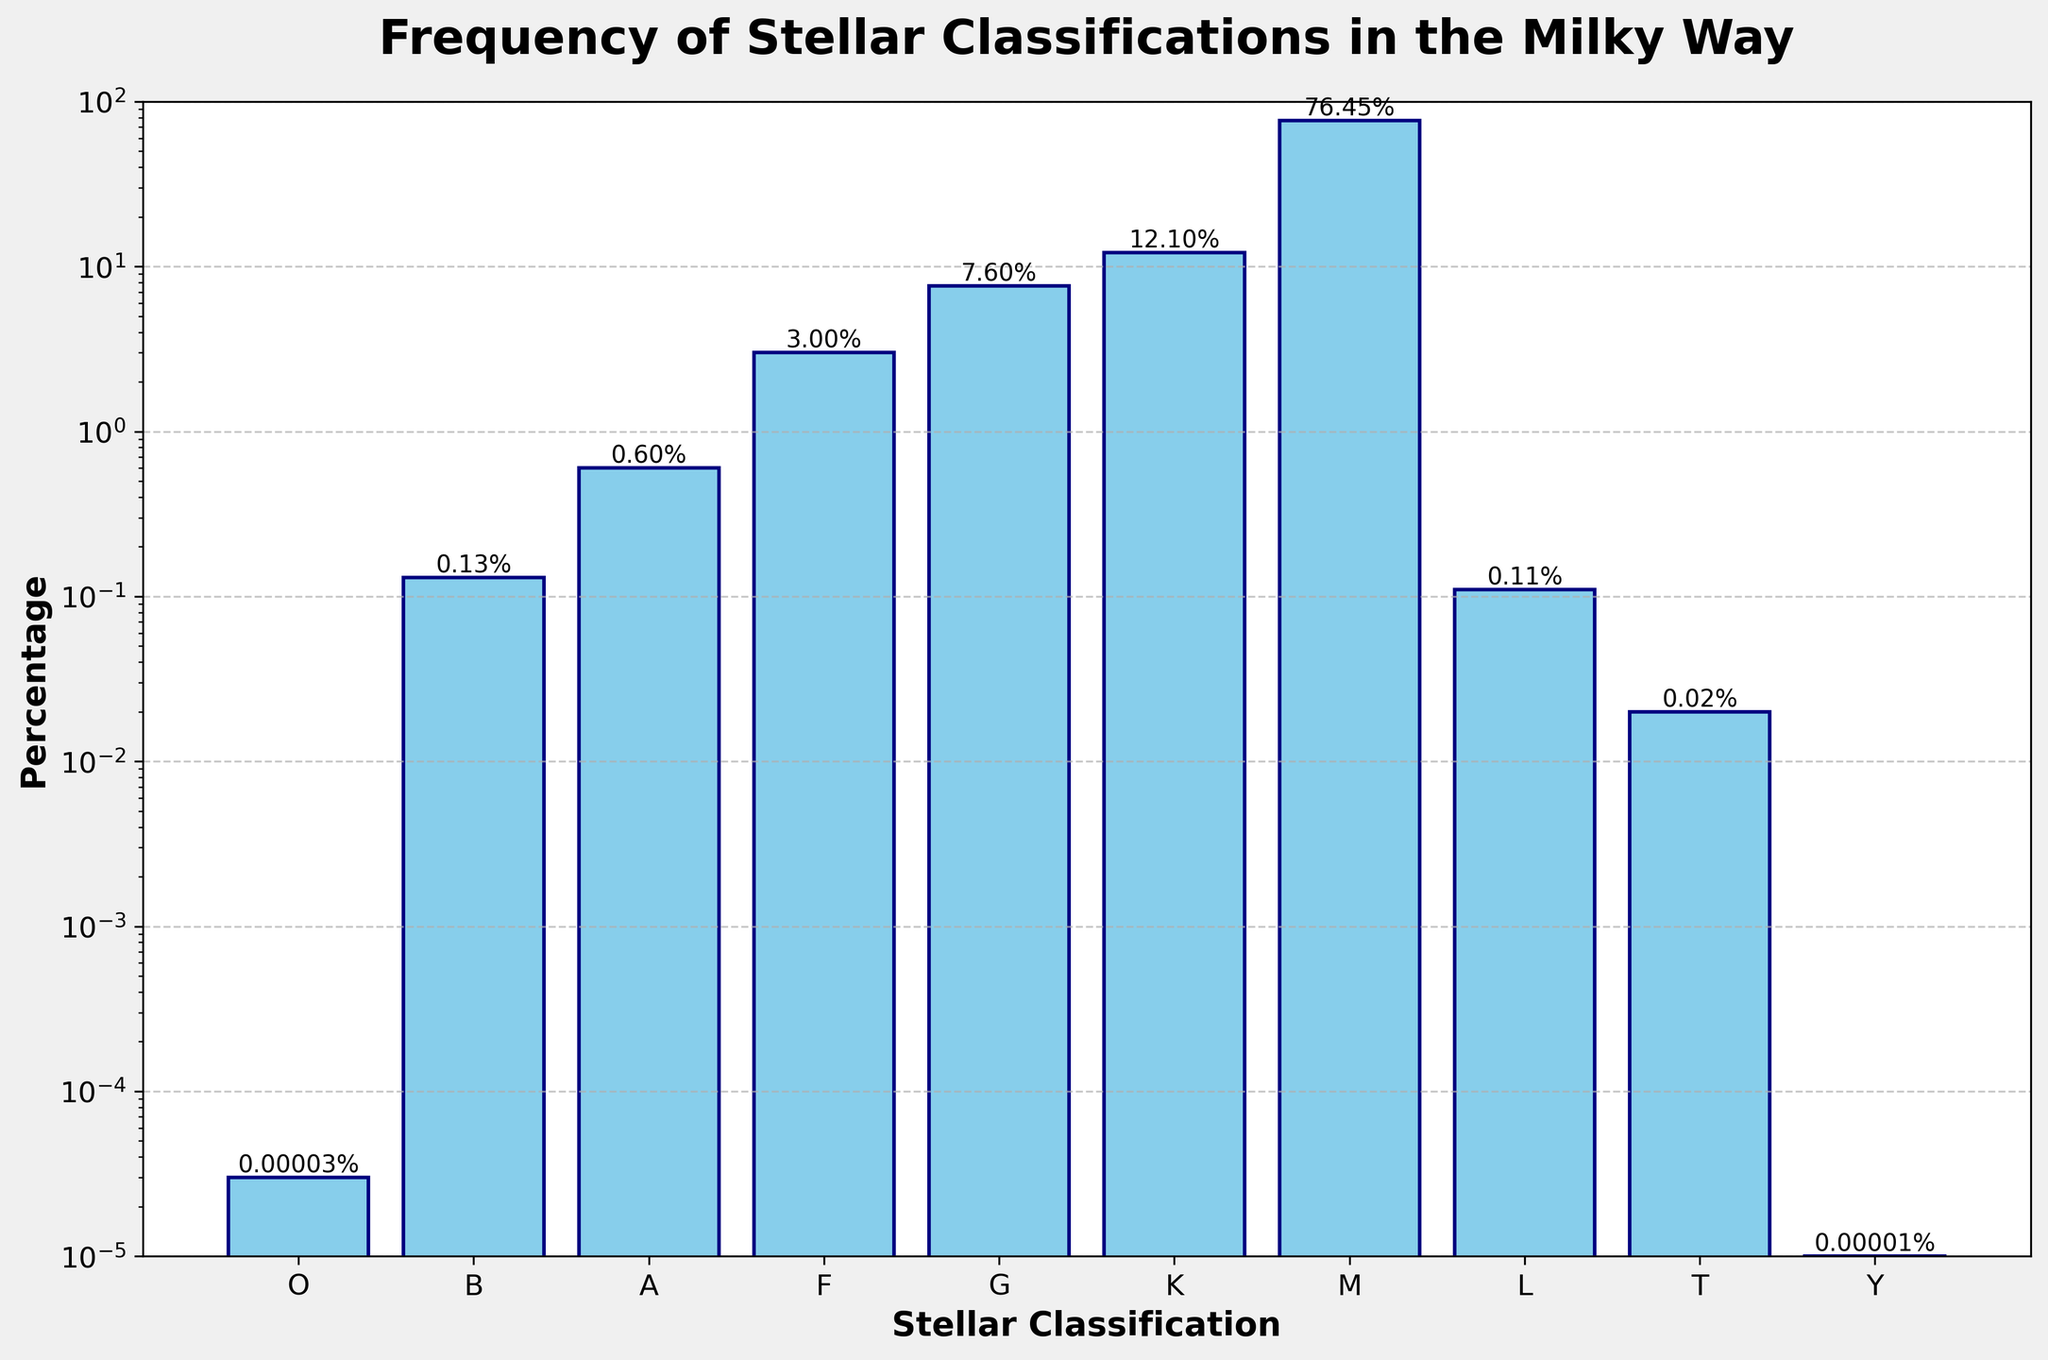Which stellar classification has the highest frequency in the Milky Way? Observing the height of the bars and their corresponding percentages, the M-class bar is the tallest, indicating it has the highest percentage. Therefore, the M-class stars occur most frequently in the Milky Way.
Answer: M Which stellar classification has the lowest frequency in the Milky Way? Among all the bars, the Y-class bar is the shortest, and its corresponding percentage is the smallest. Thus, Y-class stars have the lowest frequency.
Answer: Y What is the combined percentage of O, B, and A class stars? Adding up the percentages of O (0.00003), B (0.13), and A (0.6) class stars: 0.00003 + 0.13 + 0.6 = 0.73003%.
Answer: 0.73003% How many times more common are M-class stars compared to G-class stars? The percentage of M-class stars is 76.45%, and for G-class stars it is 7.6%. To find how many times more common M-class stars are compared to G-class stars, divide 76.45 by 7.6. 76.45 / 7.6 ≈ 10.07.
Answer: About 10 times Which is more frequent, F-class or K-class stars, and by how much? F-class stars have a percentage of 3%, while K-class stars have 12.1%. To find the difference, subtract the percentage of F from K: 12.1 - 3 = 9.1%. Thus, K-class stars are more frequent by 9.1%.
Answer: K-class by 9.1% Among the B, A, and F classes, which one has the highest frequency? Comparing the percentages directly from the figure: B (0.13%), A (0.6%), and F (3%). The F-class has the highest percentage.
Answer: F What is the percentage difference between the O and Y class stars? The percentages are 0.00003 for O-class and 0.00001 for Y-class. To find the difference, subtract the smaller value from the larger one: 0.00003 - 0.00001 = 0.00002%.
Answer: 0.00002% How does the frequency of T-class stars compare to L-class stars? The percentage of T-class stars is 0.02%, and for L-class stars it is 0.11%. Since 0.02 is less than 0.11, T-class stars are less frequent than L-class stars.
Answer: Less frequent What is the total percentage of all stellar classifications combined? Adding all the percentages: 0.00003 + 0.13 + 0.6 + 3 + 7.6 + 12.1 + 76.45 + 0.11 + 0.02 + 0.00001 = approximately 100%.
Answer: 100% Which two adjacent stellar classifications have the closest frequencies? Observing the bars in the figure and comparing adjacent values: O (0.00003) and Y (0.00001), B (0.13) and L (0.11), A (0.6) and F (3), G (7.6) and K (12.1), K (12.1) and M (76.45). The closest values are B and L with a difference of 0.13 - 0.11 = 0.02%.
Answer: B and L 